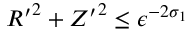Convert formula to latex. <formula><loc_0><loc_0><loc_500><loc_500>{ R ^ { \prime } } ^ { 2 } + { Z ^ { \prime } } ^ { 2 } \leq \epsilon ^ { - 2 \sigma _ { 1 } }</formula> 